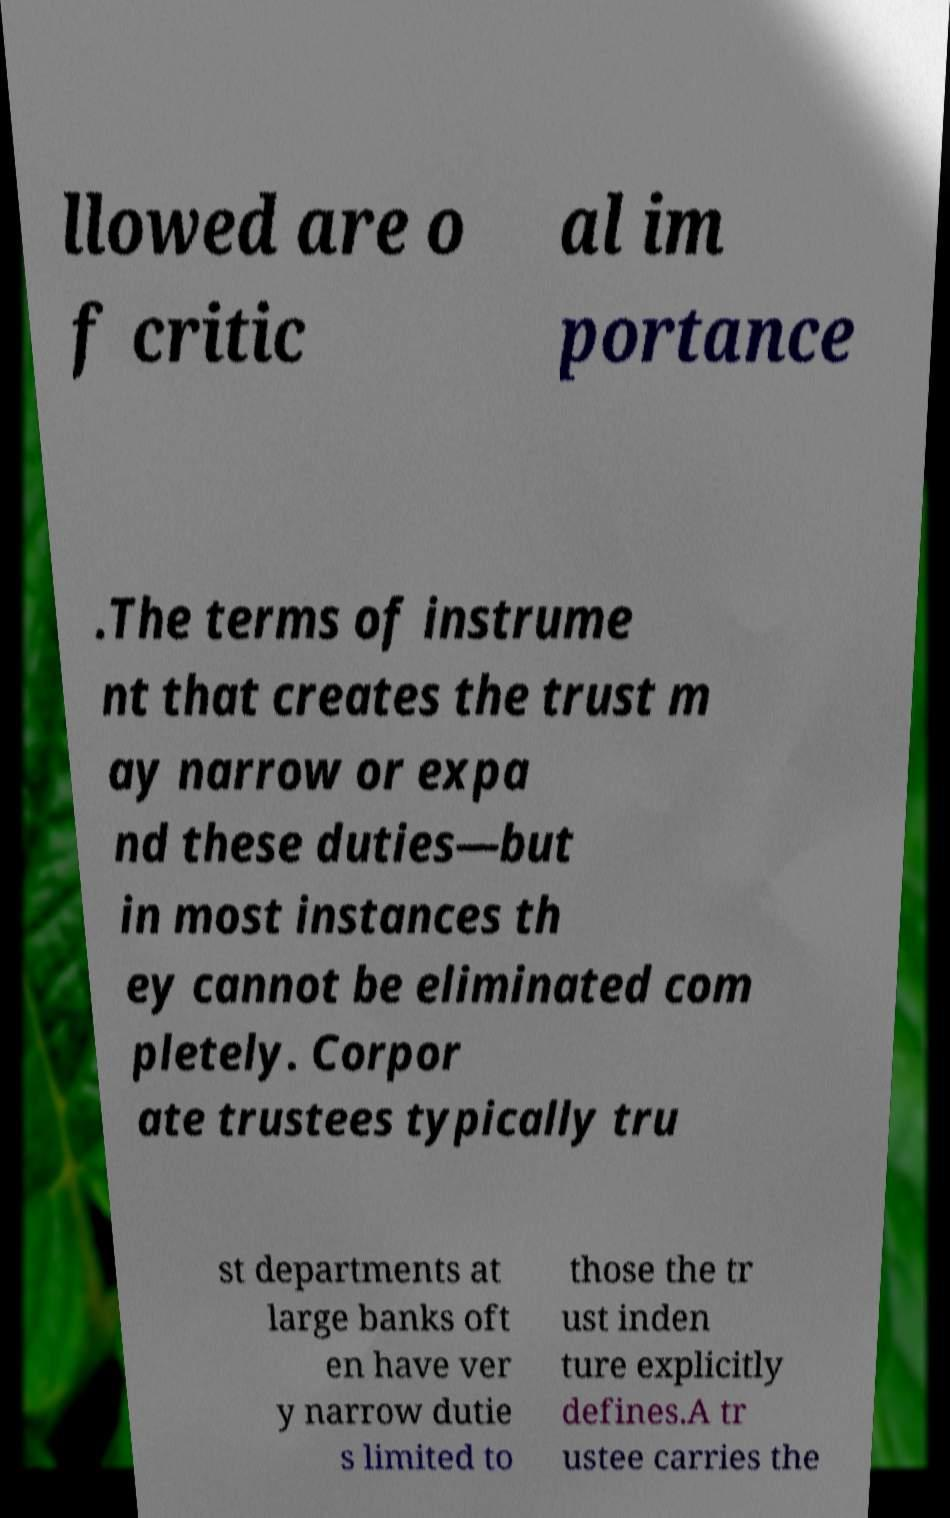There's text embedded in this image that I need extracted. Can you transcribe it verbatim? llowed are o f critic al im portance .The terms of instrume nt that creates the trust m ay narrow or expa nd these duties—but in most instances th ey cannot be eliminated com pletely. Corpor ate trustees typically tru st departments at large banks oft en have ver y narrow dutie s limited to those the tr ust inden ture explicitly defines.A tr ustee carries the 